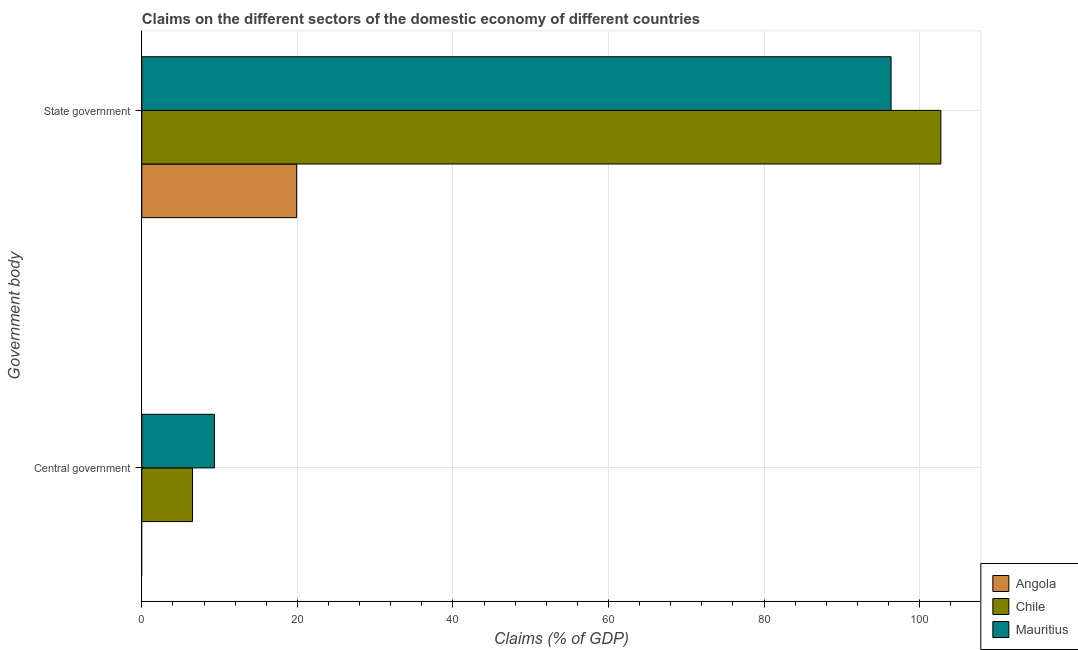How many different coloured bars are there?
Offer a terse response. 3. How many groups of bars are there?
Offer a terse response. 2. How many bars are there on the 2nd tick from the top?
Provide a succinct answer. 2. How many bars are there on the 2nd tick from the bottom?
Ensure brevity in your answer.  3. What is the label of the 2nd group of bars from the top?
Keep it short and to the point. Central government. What is the claims on central government in Chile?
Your answer should be compact. 6.52. Across all countries, what is the maximum claims on state government?
Make the answer very short. 102.72. Across all countries, what is the minimum claims on state government?
Offer a terse response. 19.91. In which country was the claims on central government maximum?
Your answer should be compact. Mauritius. What is the total claims on central government in the graph?
Offer a very short reply. 15.86. What is the difference between the claims on state government in Chile and that in Mauritius?
Keep it short and to the point. 6.4. What is the difference between the claims on state government in Chile and the claims on central government in Angola?
Keep it short and to the point. 102.72. What is the average claims on central government per country?
Your response must be concise. 5.29. What is the difference between the claims on state government and claims on central government in Mauritius?
Keep it short and to the point. 86.98. In how many countries, is the claims on state government greater than 4 %?
Keep it short and to the point. 3. What is the ratio of the claims on central government in Mauritius to that in Chile?
Keep it short and to the point. 1.43. In how many countries, is the claims on central government greater than the average claims on central government taken over all countries?
Keep it short and to the point. 2. How many countries are there in the graph?
Provide a short and direct response. 3. What is the difference between two consecutive major ticks on the X-axis?
Make the answer very short. 20. Does the graph contain any zero values?
Offer a very short reply. Yes. How many legend labels are there?
Provide a succinct answer. 3. How are the legend labels stacked?
Give a very brief answer. Vertical. What is the title of the graph?
Ensure brevity in your answer.  Claims on the different sectors of the domestic economy of different countries. What is the label or title of the X-axis?
Your response must be concise. Claims (% of GDP). What is the label or title of the Y-axis?
Give a very brief answer. Government body. What is the Claims (% of GDP) in Chile in Central government?
Offer a very short reply. 6.52. What is the Claims (% of GDP) in Mauritius in Central government?
Provide a short and direct response. 9.34. What is the Claims (% of GDP) in Angola in State government?
Give a very brief answer. 19.91. What is the Claims (% of GDP) in Chile in State government?
Give a very brief answer. 102.72. What is the Claims (% of GDP) of Mauritius in State government?
Your answer should be compact. 96.32. Across all Government body, what is the maximum Claims (% of GDP) in Angola?
Give a very brief answer. 19.91. Across all Government body, what is the maximum Claims (% of GDP) in Chile?
Provide a short and direct response. 102.72. Across all Government body, what is the maximum Claims (% of GDP) in Mauritius?
Offer a terse response. 96.32. Across all Government body, what is the minimum Claims (% of GDP) of Chile?
Offer a very short reply. 6.52. Across all Government body, what is the minimum Claims (% of GDP) in Mauritius?
Your response must be concise. 9.34. What is the total Claims (% of GDP) of Angola in the graph?
Provide a short and direct response. 19.91. What is the total Claims (% of GDP) in Chile in the graph?
Your answer should be very brief. 109.24. What is the total Claims (% of GDP) in Mauritius in the graph?
Offer a very short reply. 105.66. What is the difference between the Claims (% of GDP) of Chile in Central government and that in State government?
Provide a short and direct response. -96.2. What is the difference between the Claims (% of GDP) of Mauritius in Central government and that in State government?
Your answer should be compact. -86.98. What is the difference between the Claims (% of GDP) in Chile in Central government and the Claims (% of GDP) in Mauritius in State government?
Your answer should be compact. -89.8. What is the average Claims (% of GDP) of Angola per Government body?
Provide a succinct answer. 9.95. What is the average Claims (% of GDP) of Chile per Government body?
Your answer should be very brief. 54.62. What is the average Claims (% of GDP) in Mauritius per Government body?
Your answer should be very brief. 52.83. What is the difference between the Claims (% of GDP) in Chile and Claims (% of GDP) in Mauritius in Central government?
Your response must be concise. -2.82. What is the difference between the Claims (% of GDP) in Angola and Claims (% of GDP) in Chile in State government?
Provide a succinct answer. -82.81. What is the difference between the Claims (% of GDP) of Angola and Claims (% of GDP) of Mauritius in State government?
Offer a very short reply. -76.41. What is the difference between the Claims (% of GDP) of Chile and Claims (% of GDP) of Mauritius in State government?
Your response must be concise. 6.4. What is the ratio of the Claims (% of GDP) in Chile in Central government to that in State government?
Offer a very short reply. 0.06. What is the ratio of the Claims (% of GDP) in Mauritius in Central government to that in State government?
Ensure brevity in your answer.  0.1. What is the difference between the highest and the second highest Claims (% of GDP) in Chile?
Provide a short and direct response. 96.2. What is the difference between the highest and the second highest Claims (% of GDP) in Mauritius?
Give a very brief answer. 86.98. What is the difference between the highest and the lowest Claims (% of GDP) in Angola?
Your response must be concise. 19.91. What is the difference between the highest and the lowest Claims (% of GDP) in Chile?
Your answer should be very brief. 96.2. What is the difference between the highest and the lowest Claims (% of GDP) in Mauritius?
Provide a succinct answer. 86.98. 